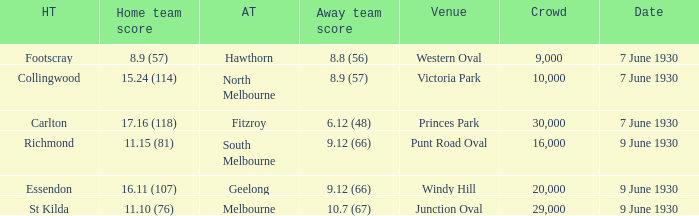What away team played Footscray? Hawthorn. 